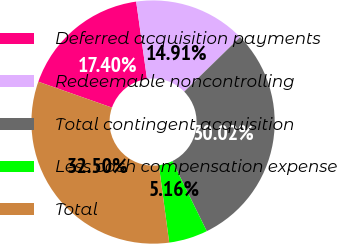<chart> <loc_0><loc_0><loc_500><loc_500><pie_chart><fcel>Deferred acquisition payments<fcel>Redeemable noncontrolling<fcel>Total contingent acquisition<fcel>Less cash compensation expense<fcel>Total<nl><fcel>17.4%<fcel>14.91%<fcel>30.02%<fcel>5.16%<fcel>32.5%<nl></chart> 